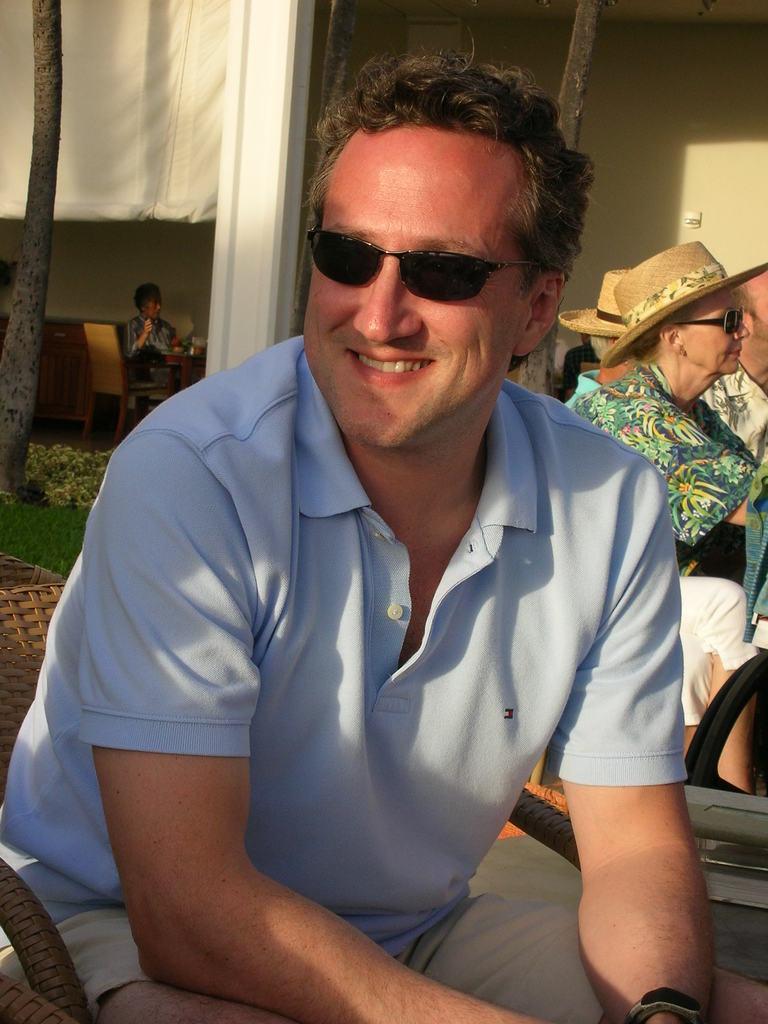Please provide a concise description of this image. In this image there is a man in the center sitting and smiling. In the background there are persons sitting and on the left side there is a tree and there is a white colour curtain. On the ground there is grass 